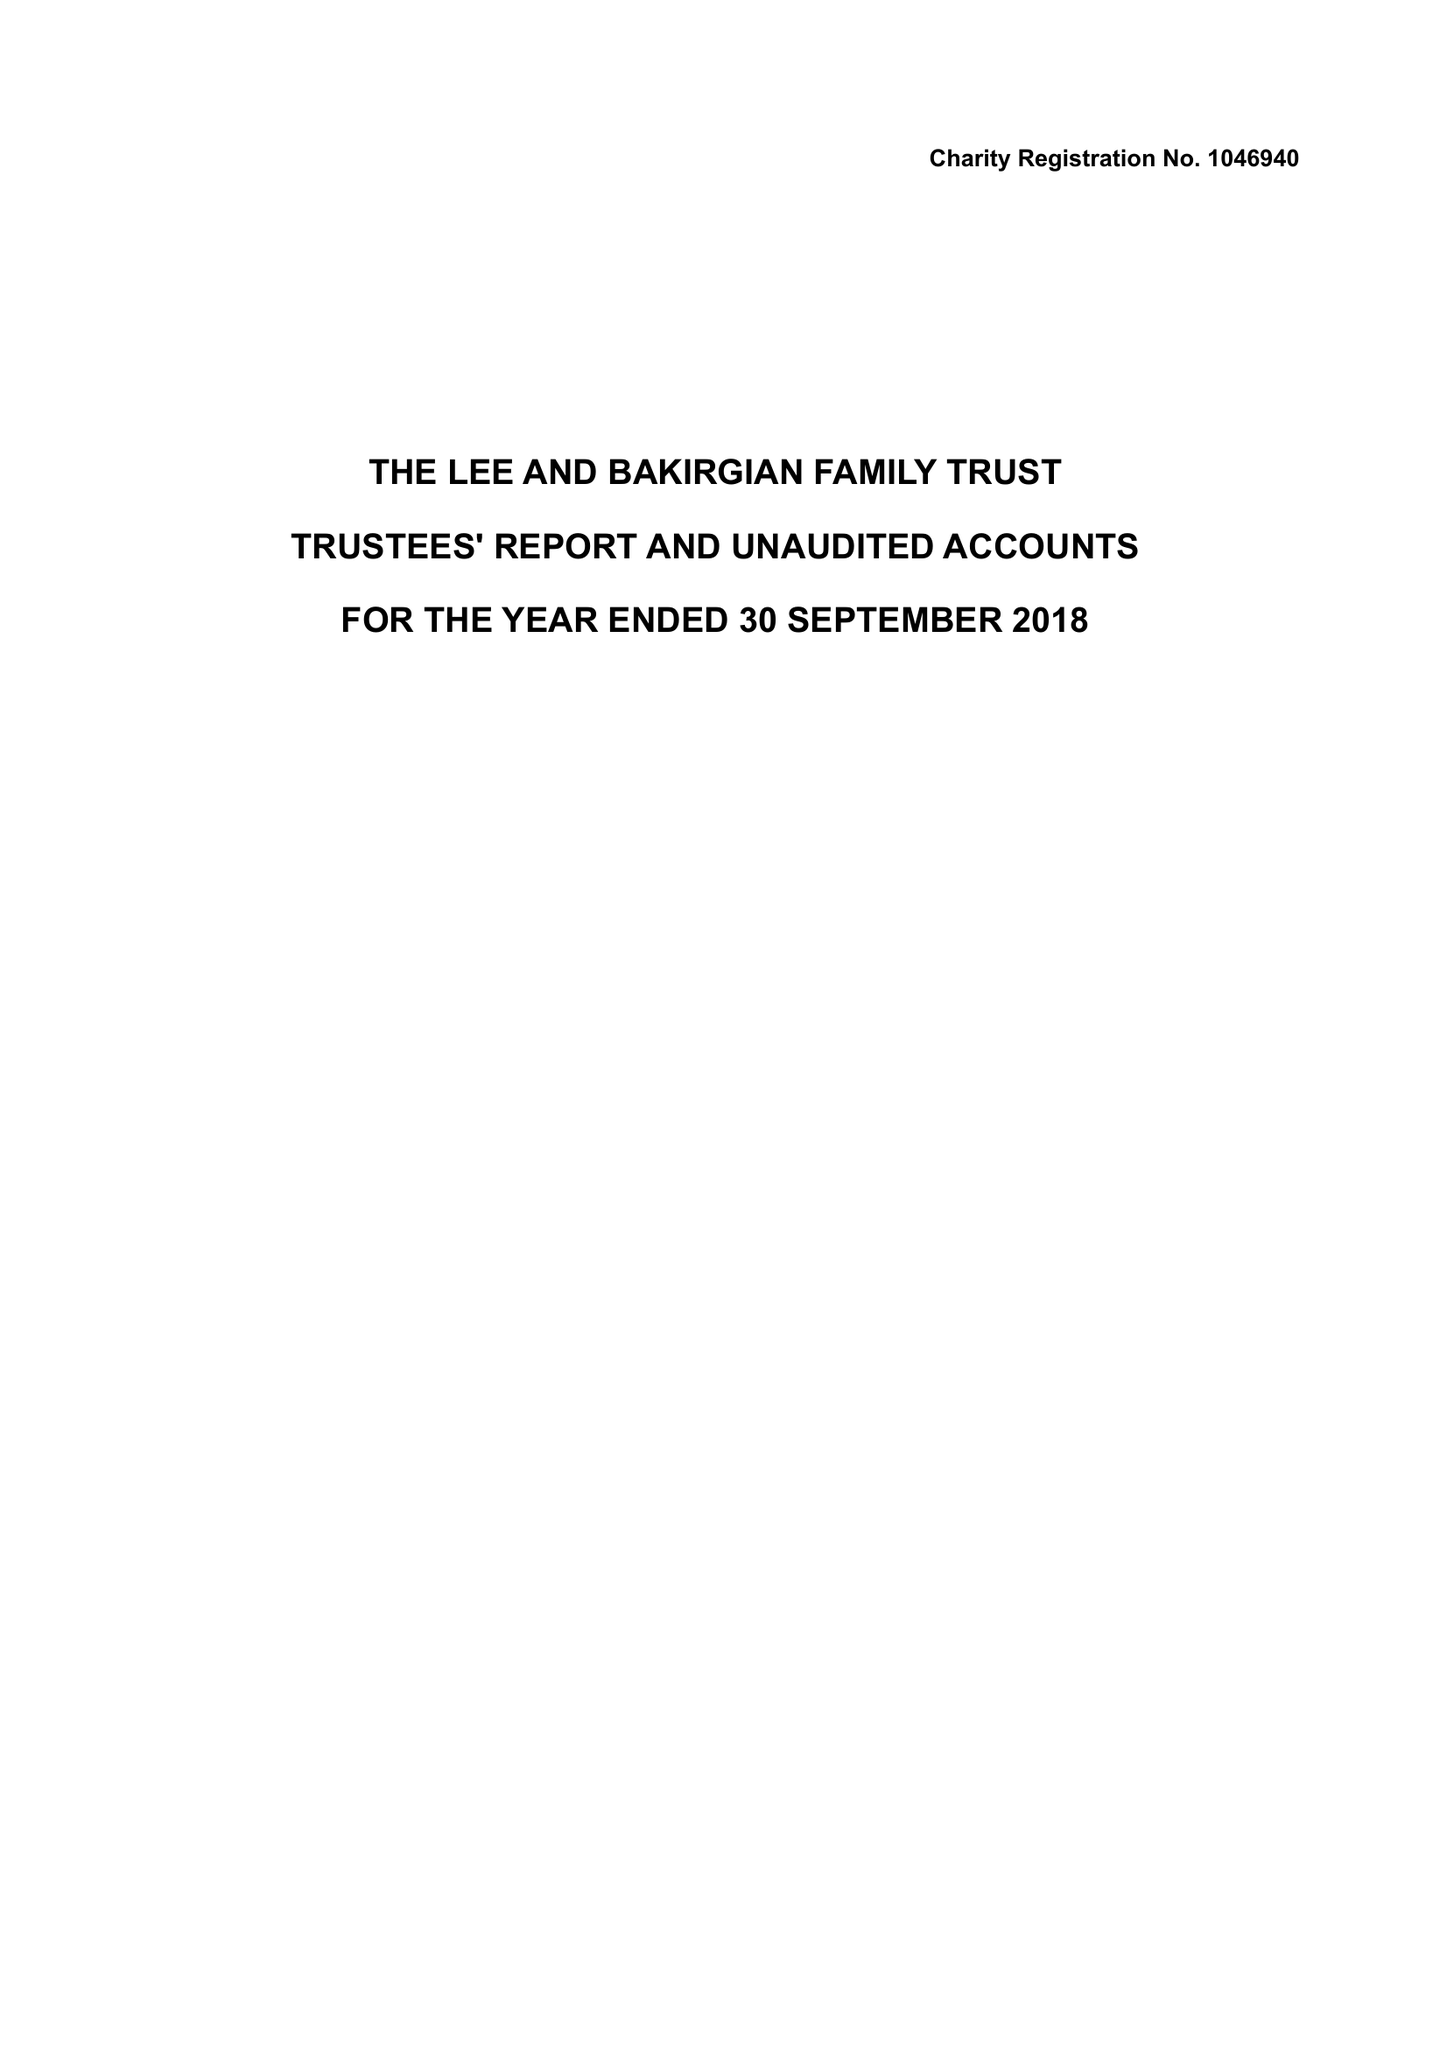What is the value for the income_annually_in_british_pounds?
Answer the question using a single word or phrase. 29943.00 